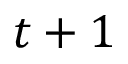<formula> <loc_0><loc_0><loc_500><loc_500>t + 1</formula> 